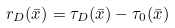<formula> <loc_0><loc_0><loc_500><loc_500>r _ { D } ( \bar { x } ) = \tau _ { D } ( \bar { x } ) - \tau _ { 0 } ( \bar { x } )</formula> 